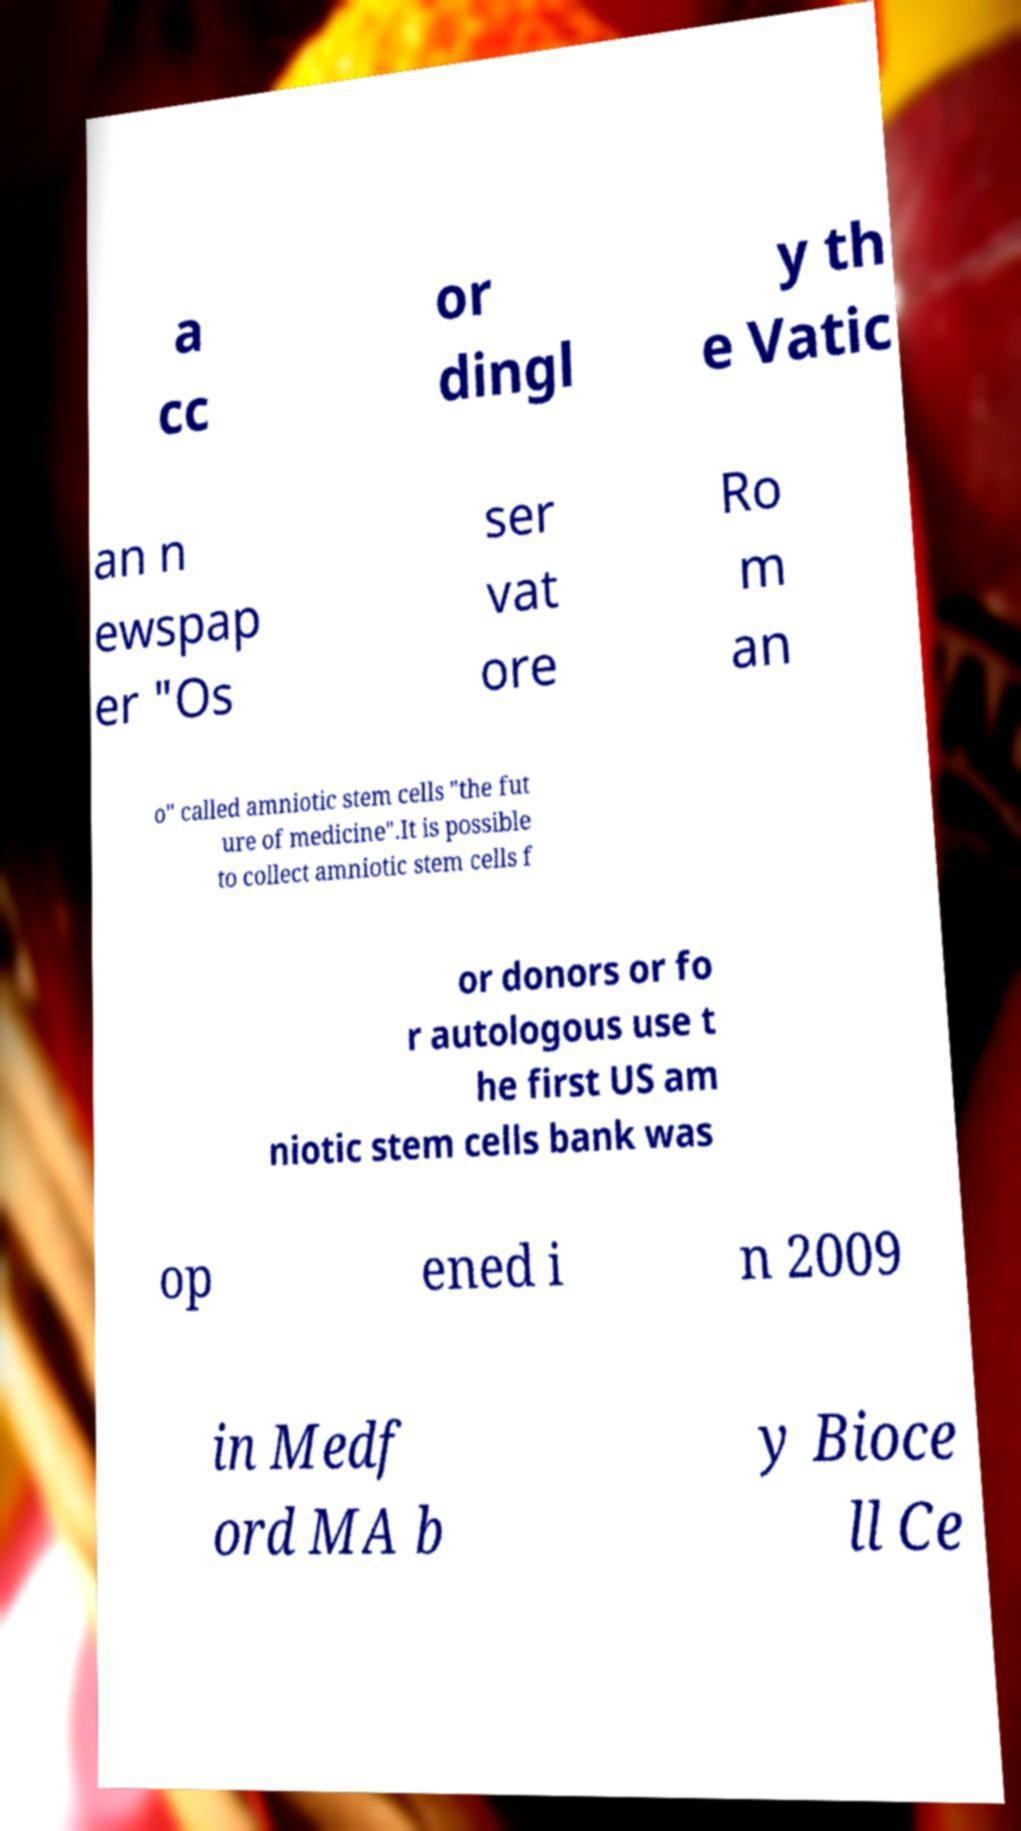What messages or text are displayed in this image? I need them in a readable, typed format. a cc or dingl y th e Vatic an n ewspap er "Os ser vat ore Ro m an o" called amniotic stem cells "the fut ure of medicine".It is possible to collect amniotic stem cells f or donors or fo r autologous use t he first US am niotic stem cells bank was op ened i n 2009 in Medf ord MA b y Bioce ll Ce 